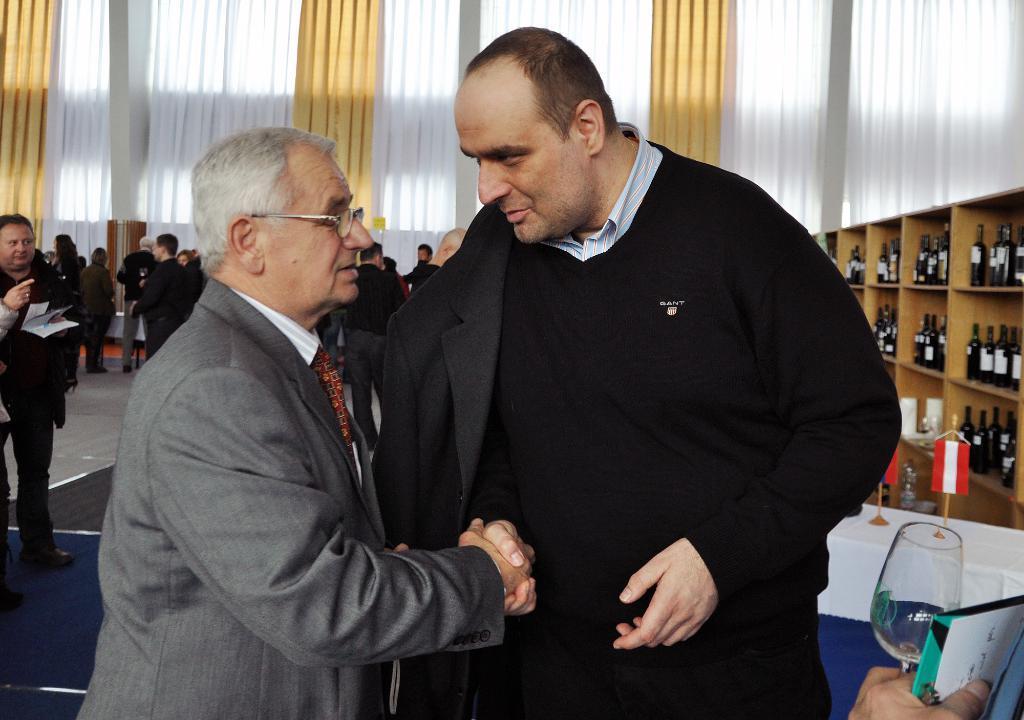In one or two sentences, can you explain what this image depicts? On the left side, there is a person in a suit wearing spectacle and shaking hands with another person who is in black color jacket. In the background, there are bottles arranged on the shelves, there are persons on the floor and there are curtains. 